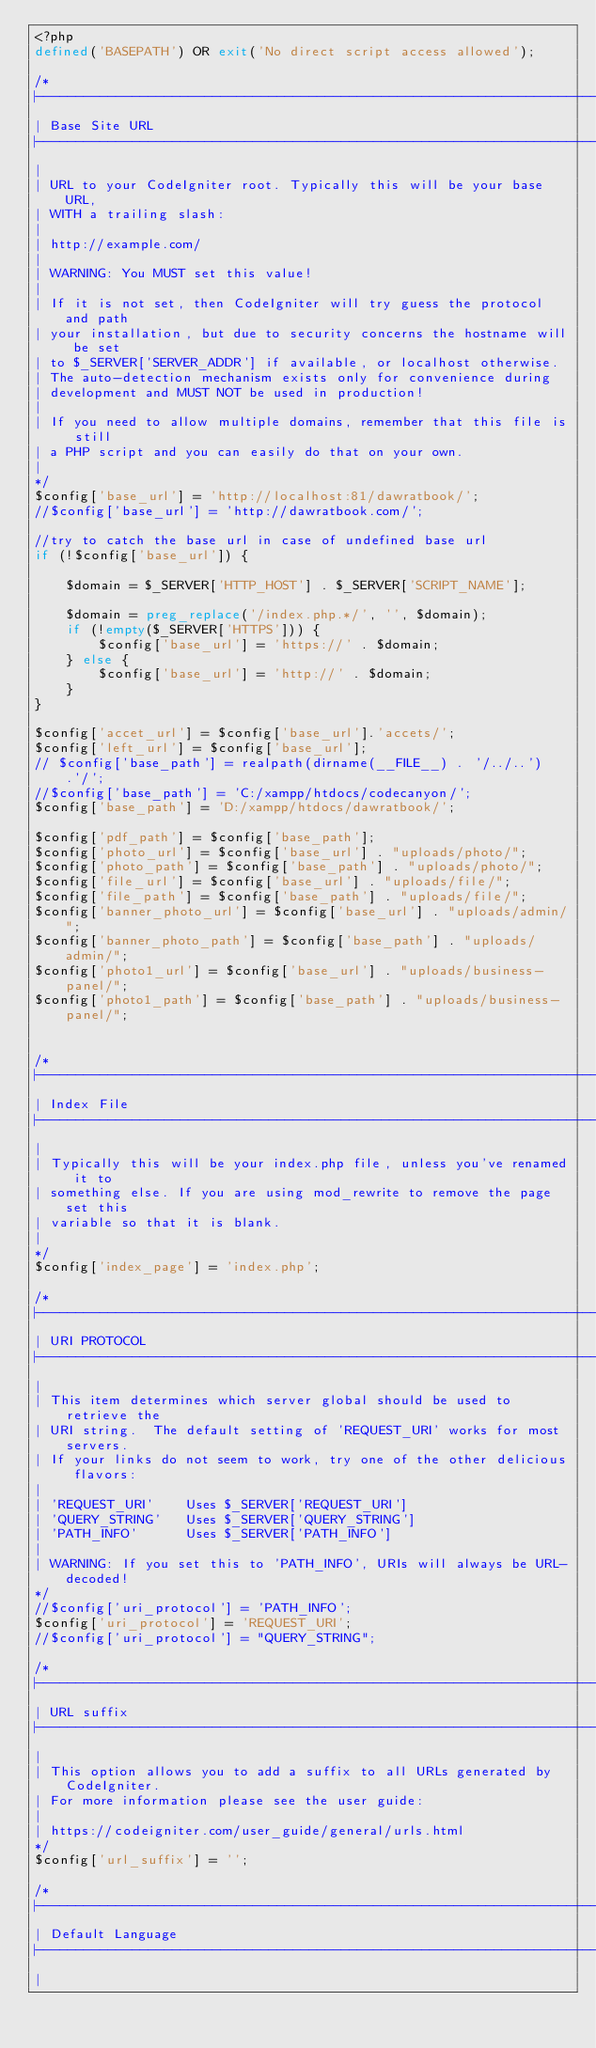Convert code to text. <code><loc_0><loc_0><loc_500><loc_500><_PHP_><?php
defined('BASEPATH') OR exit('No direct script access allowed');

/*
|--------------------------------------------------------------------------
| Base Site URL
|--------------------------------------------------------------------------
|
| URL to your CodeIgniter root. Typically this will be your base URL,
| WITH a trailing slash:
|
|	http://example.com/
|
| WARNING: You MUST set this value!
|
| If it is not set, then CodeIgniter will try guess the protocol and path
| your installation, but due to security concerns the hostname will be set
| to $_SERVER['SERVER_ADDR'] if available, or localhost otherwise.
| The auto-detection mechanism exists only for convenience during
| development and MUST NOT be used in production!
|
| If you need to allow multiple domains, remember that this file is still
| a PHP script and you can easily do that on your own.
|
*/
$config['base_url'] = 'http://localhost:81/dawratbook/';
//$config['base_url'] = 'http://dawratbook.com/';

//try to catch the base url in case of undefined base url 
if (!$config['base_url']) {

    $domain = $_SERVER['HTTP_HOST'] . $_SERVER['SCRIPT_NAME'];

    $domain = preg_replace('/index.php.*/', '', $domain);
    if (!empty($_SERVER['HTTPS'])) {
        $config['base_url'] = 'https://' . $domain;
    } else {
        $config['base_url'] = 'http://' . $domain;
    }
}

$config['accet_url'] = $config['base_url'].'accets/';
$config['left_url'] = $config['base_url'];
// $config['base_path'] = realpath(dirname(__FILE__) . '/../..').'/';
//$config['base_path'] = 'C:/xampp/htdocs/codecanyon/';
$config['base_path'] = 'D:/xampp/htdocs/dawratbook/';

$config['pdf_path'] = $config['base_path'];
$config['photo_url'] = $config['base_url'] . "uploads/photo/";
$config['photo_path'] = $config['base_path'] . "uploads/photo/";
$config['file_url'] = $config['base_url'] . "uploads/file/";
$config['file_path'] = $config['base_path'] . "uploads/file/";
$config['banner_photo_url'] = $config['base_url'] . "uploads/admin/";
$config['banner_photo_path'] = $config['base_path'] . "uploads/admin/";
$config['photo1_url'] = $config['base_url'] . "uploads/business-panel/";
$config['photo1_path'] = $config['base_path'] . "uploads/business-panel/";


/*
|--------------------------------------------------------------------------
| Index File
|--------------------------------------------------------------------------
|
| Typically this will be your index.php file, unless you've renamed it to
| something else. If you are using mod_rewrite to remove the page set this
| variable so that it is blank.
|
*/
$config['index_page'] = 'index.php';

/*
|--------------------------------------------------------------------------
| URI PROTOCOL
|--------------------------------------------------------------------------
|
| This item determines which server global should be used to retrieve the
| URI string.  The default setting of 'REQUEST_URI' works for most servers.
| If your links do not seem to work, try one of the other delicious flavors:
|
| 'REQUEST_URI'    Uses $_SERVER['REQUEST_URI']
| 'QUERY_STRING'   Uses $_SERVER['QUERY_STRING']
| 'PATH_INFO'      Uses $_SERVER['PATH_INFO']
|
| WARNING: If you set this to 'PATH_INFO', URIs will always be URL-decoded!
*/
//$config['uri_protocol']	= 'PATH_INFO';
$config['uri_protocol']	= 'REQUEST_URI';
//$config['uri_protocol'] = "QUERY_STRING";

/*
|--------------------------------------------------------------------------
| URL suffix
|--------------------------------------------------------------------------
|
| This option allows you to add a suffix to all URLs generated by CodeIgniter.
| For more information please see the user guide:
|
| https://codeigniter.com/user_guide/general/urls.html
*/
$config['url_suffix'] = '';

/*
|--------------------------------------------------------------------------
| Default Language
|--------------------------------------------------------------------------
|</code> 